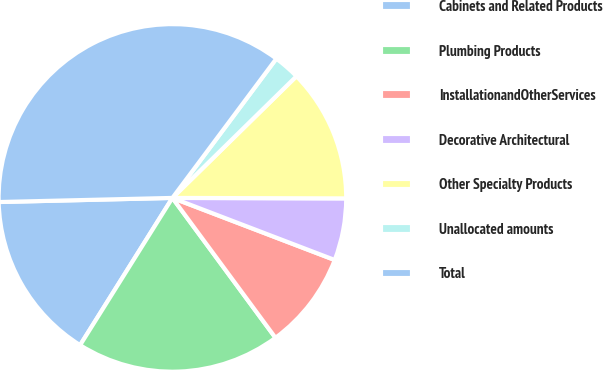Convert chart to OTSL. <chart><loc_0><loc_0><loc_500><loc_500><pie_chart><fcel>Cabinets and Related Products<fcel>Plumbing Products<fcel>InstallationandOtherServices<fcel>Decorative Architectural<fcel>Other Specialty Products<fcel>Unallocated amounts<fcel>Total<nl><fcel>15.71%<fcel>19.02%<fcel>9.08%<fcel>5.77%<fcel>12.39%<fcel>2.45%<fcel>35.58%<nl></chart> 